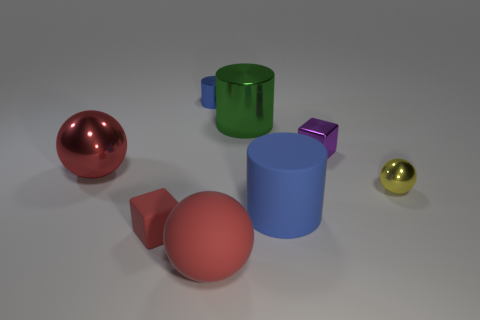Add 1 large rubber spheres. How many objects exist? 9 Subtract all blocks. How many objects are left? 6 Subtract 0 gray cylinders. How many objects are left? 8 Subtract all green things. Subtract all tiny metal things. How many objects are left? 4 Add 5 tiny purple shiny cubes. How many tiny purple shiny cubes are left? 6 Add 8 small red rubber things. How many small red rubber things exist? 9 